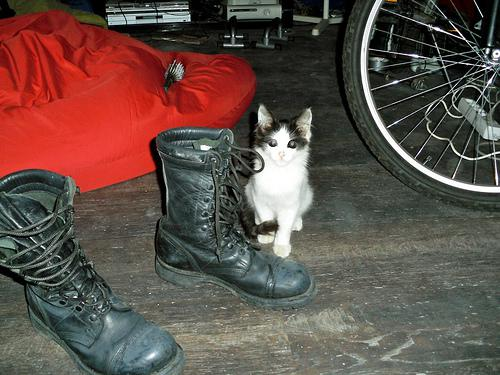Question: where was the picture taken?
Choices:
A. Zoo.
B. Field.
C. In a park.
D. Hill.
Answer with the letter. Answer: C Question: what is behind the cat?
Choices:
A. A wheel.
B. A car.
C. A bus.
D. A truck.
Answer with the letter. Answer: A 